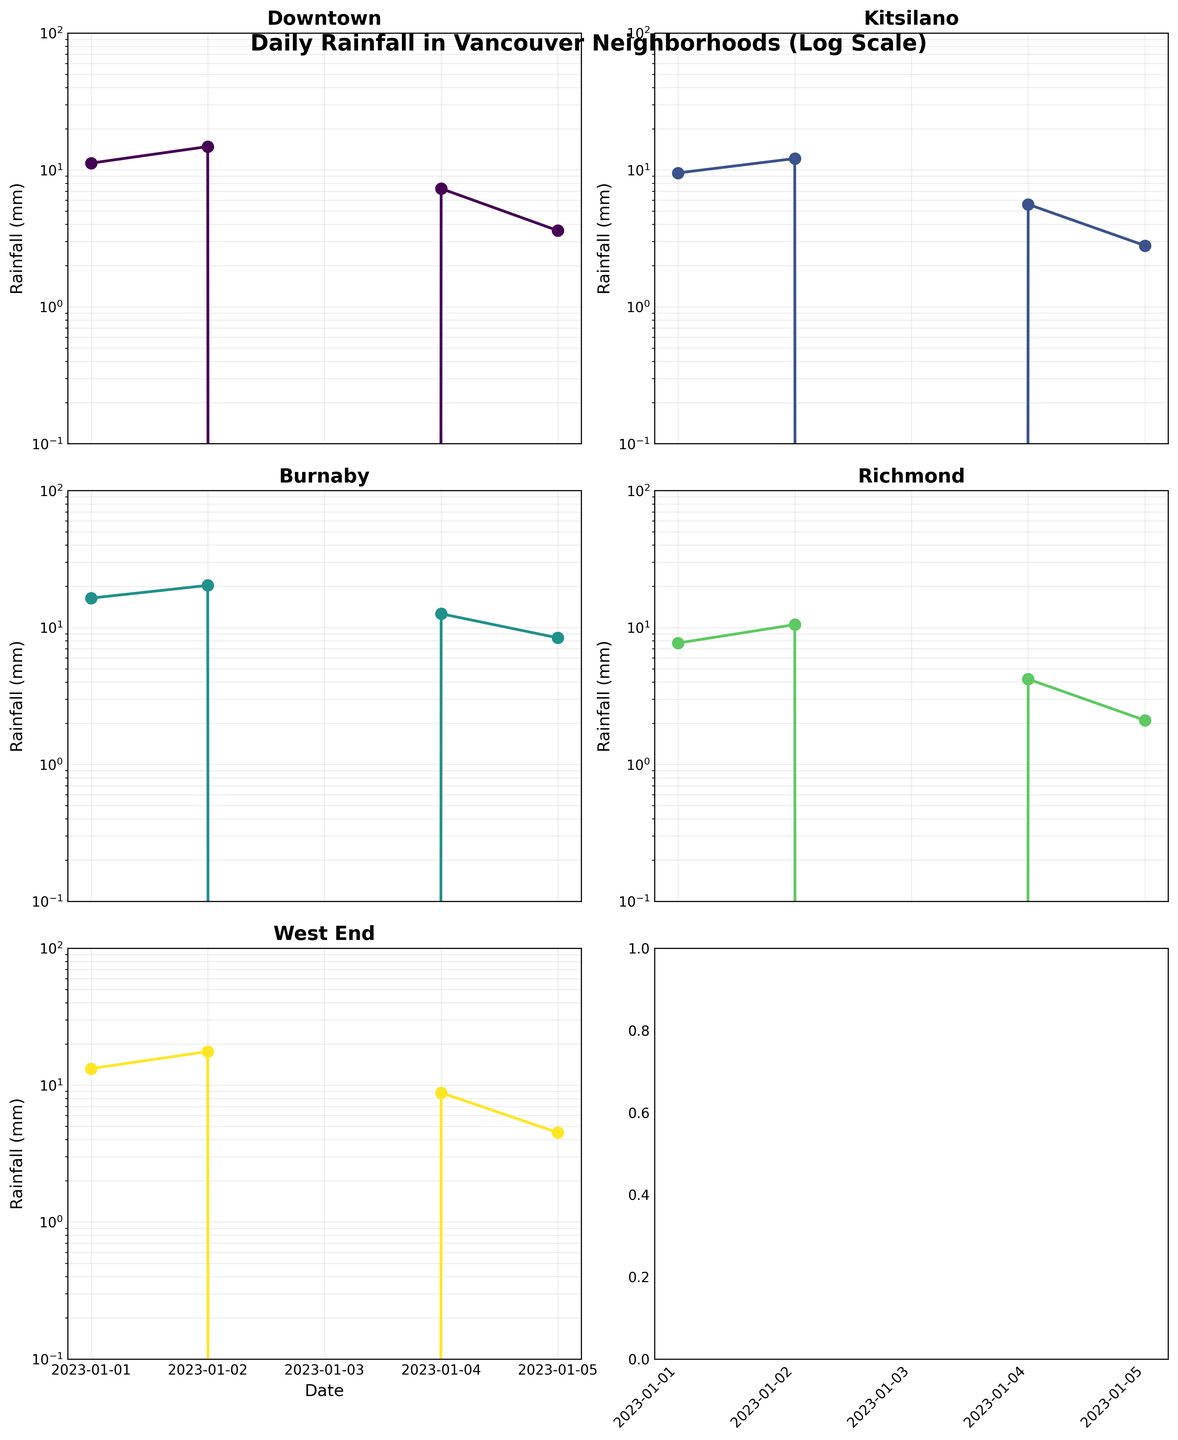How many neighborhoods are represented in the plot? There are separate subplots for each neighborhood, so counting the titles of each subplot will give the number of neighborhoods.
Answer: 5 Which neighborhood had the highest rainfall on January 2, 2023? On January 2, you compare the heights of the points for each neighborhood's subplot. Burnaby has the highest point on that date.
Answer: Burnaby What is the range of rainfall values shown on the y-axis? The y-axis is on a log scale and ranges from 0.1 mm to 100 mm, as indicated on the axis labels and tick marks.
Answer: 0.1 mm to 100 mm Which neighborhood had a rainfall value of 0 mm on January 3, 2023? Looking at the points for January 3 in each subplot, all neighborhoods have a point at the baseline (0 mm).
Answer: All neighborhoods How does the rainfall in Downtown compare to West End on January 5, 2023? Check the heights of the points on January 5 for both Downtown and West End subplots. Downtown's value is lower than West End's.
Answer: Lower What is the total rainfall for Kitsilano over the 5-day period? Sum the rainfall values for Kitsilano: 9.5 + 12.1 + 0.0 + 5.6 + 2.8
Answer: 30.0 mm On which date did Richmond have the least rainfall? Compare the points in the Richmond subplot to see which date has the lowest value. January 3 has 0 mm, which is the least.
Answer: January 3, 2023 Which two neighborhoods had the closest rainfall values on January 4, and what were their values? Compare the heights of the points on January 4. Downtown and Richmond have the closest values, at 7.3 mm and 4.2 mm, respectively.
Answer: Downtown: 7.3 mm, Richmond: 4.2 mm What is the median rainfall for Burnaby over the given dates? Arrange Burnaby's rainfall values in ascending order and find the median: 0.0, 8.4, 12.6, 16.4, 20.3. The median is the third value, 12.6 mm.
Answer: 12.6 mm Which neighborhood experienced the largest daily variation in rainfall? Look for the neighborhood with the largest difference between its highest and lowest points. Burnaby has the highest value at 20.3 mm and a low of 0.0 mm, giving a variation of 20.3 mm.
Answer: Burnaby 